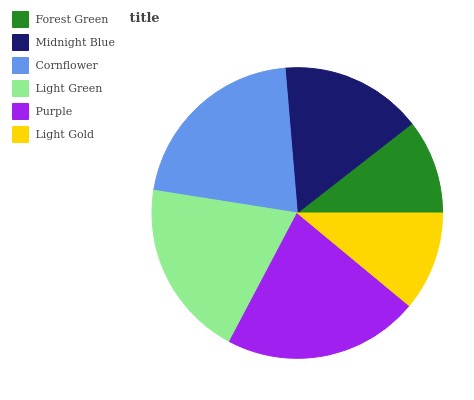Is Forest Green the minimum?
Answer yes or no. Yes. Is Purple the maximum?
Answer yes or no. Yes. Is Midnight Blue the minimum?
Answer yes or no. No. Is Midnight Blue the maximum?
Answer yes or no. No. Is Midnight Blue greater than Forest Green?
Answer yes or no. Yes. Is Forest Green less than Midnight Blue?
Answer yes or no. Yes. Is Forest Green greater than Midnight Blue?
Answer yes or no. No. Is Midnight Blue less than Forest Green?
Answer yes or no. No. Is Light Green the high median?
Answer yes or no. Yes. Is Midnight Blue the low median?
Answer yes or no. Yes. Is Light Gold the high median?
Answer yes or no. No. Is Light Gold the low median?
Answer yes or no. No. 